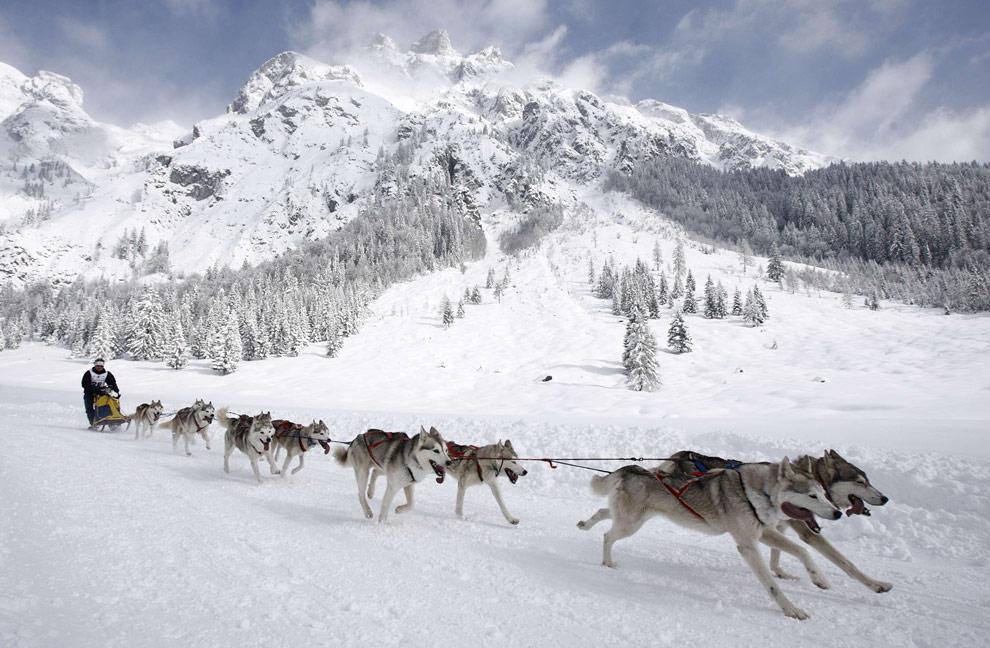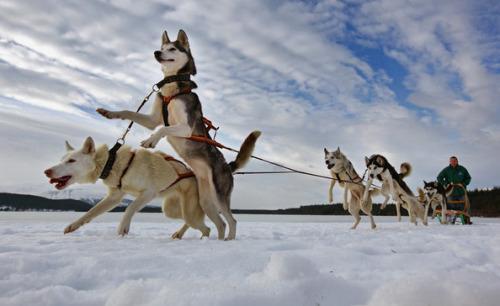The first image is the image on the left, the second image is the image on the right. Given the left and right images, does the statement "The dogs are heading toward the left in the image on the right." hold true? Answer yes or no. Yes. The first image is the image on the left, the second image is the image on the right. Given the left and right images, does the statement "Both images show sled dog teams headed rightward and downward." hold true? Answer yes or no. No. 